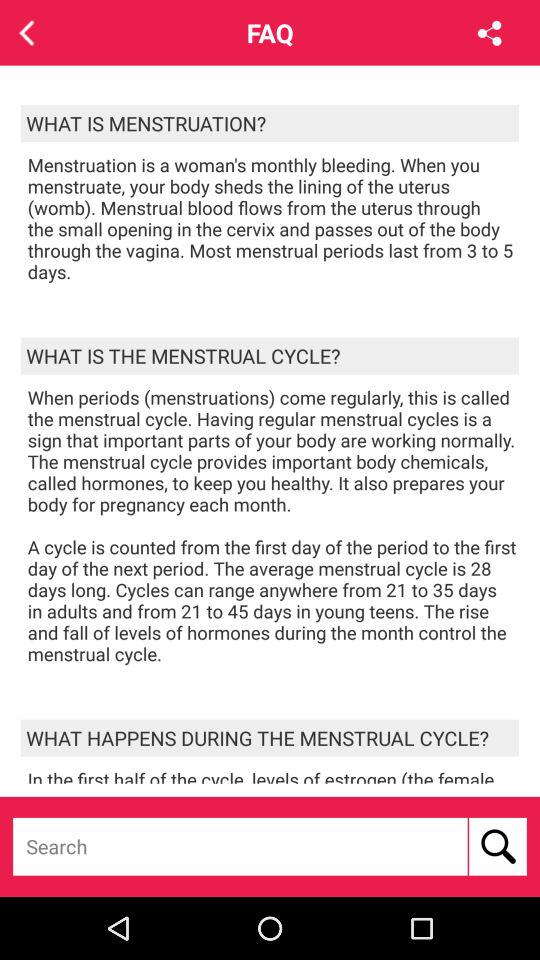What is the average menstrual cycle timing range for teens? The average timing range is 21 to 45 days. 